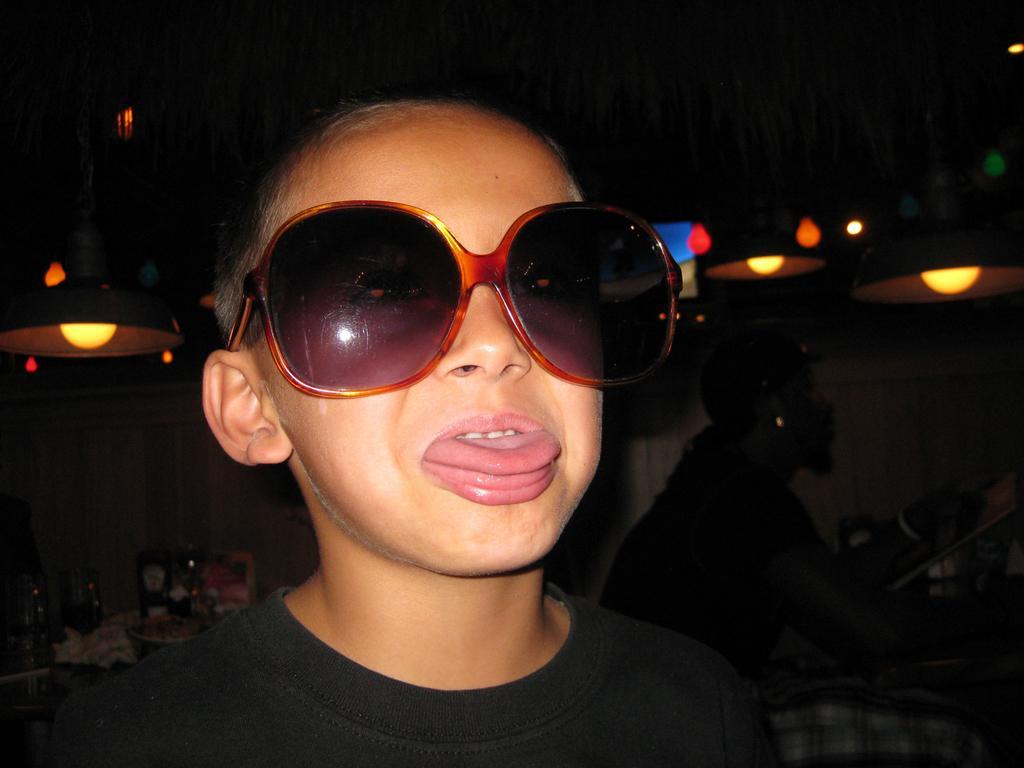Describe this image in one or two sentences. In this image I can see there is a kid and is wearing goggles, there are few persons in the background and there are few lights attached to the ceiling. 